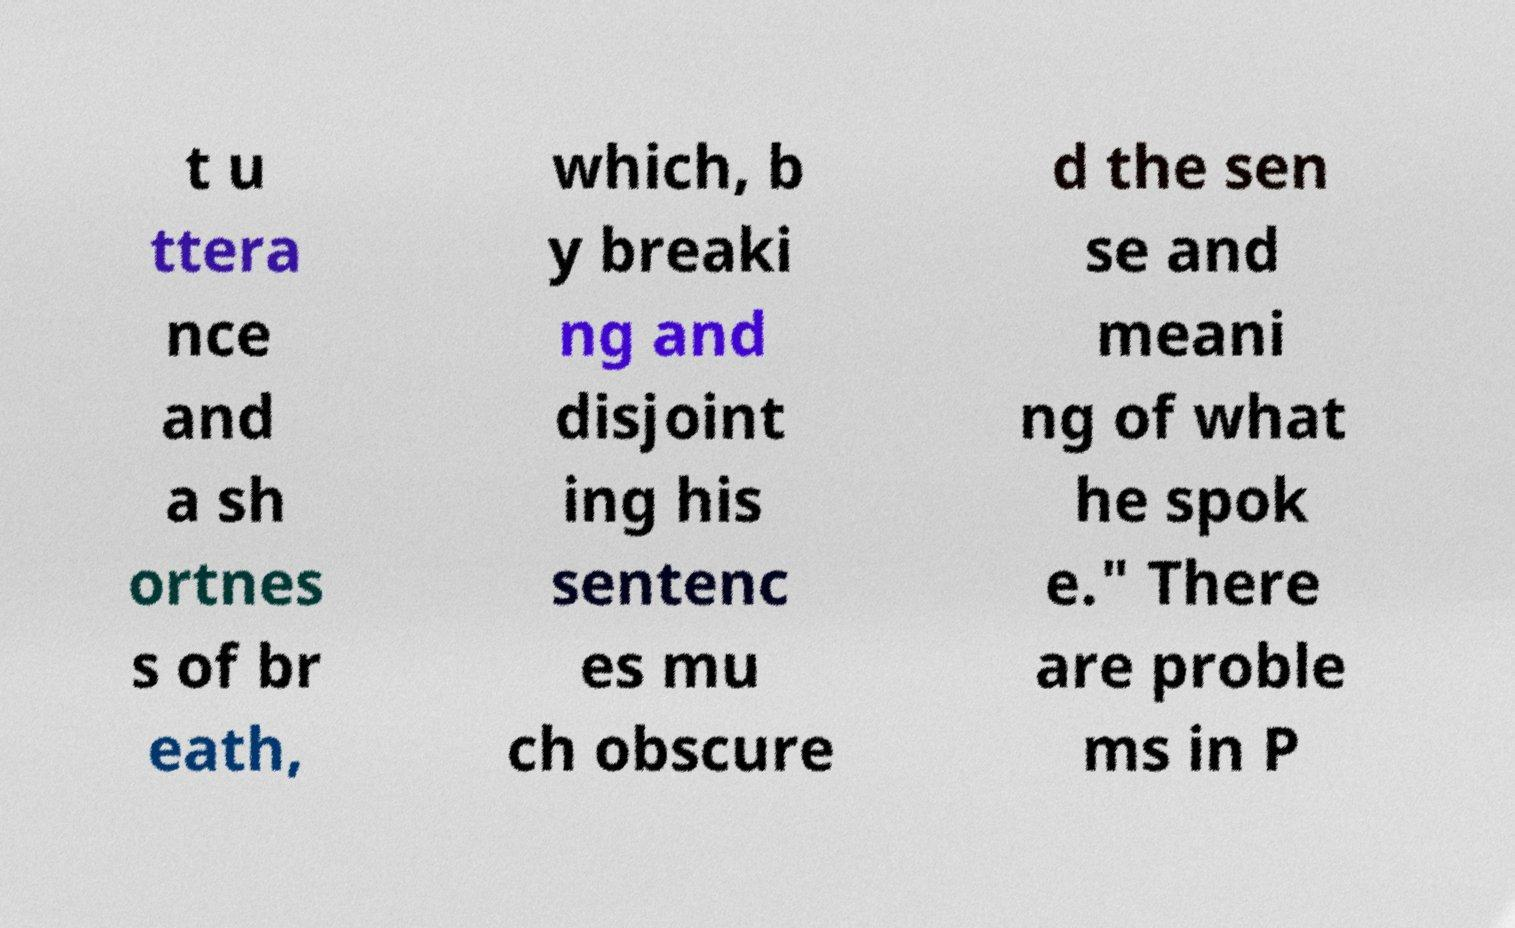Can you read and provide the text displayed in the image?This photo seems to have some interesting text. Can you extract and type it out for me? t u ttera nce and a sh ortnes s of br eath, which, b y breaki ng and disjoint ing his sentenc es mu ch obscure d the sen se and meani ng of what he spok e." There are proble ms in P 